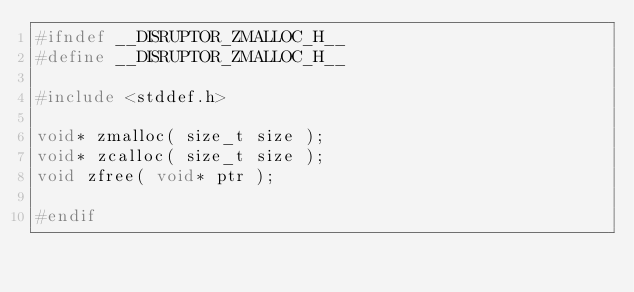<code> <loc_0><loc_0><loc_500><loc_500><_C_>#ifndef __DISRUPTOR_ZMALLOC_H__
#define __DISRUPTOR_ZMALLOC_H__

#include <stddef.h>

void* zmalloc( size_t size );
void* zcalloc( size_t size );
void zfree( void* ptr );

#endif

</code> 